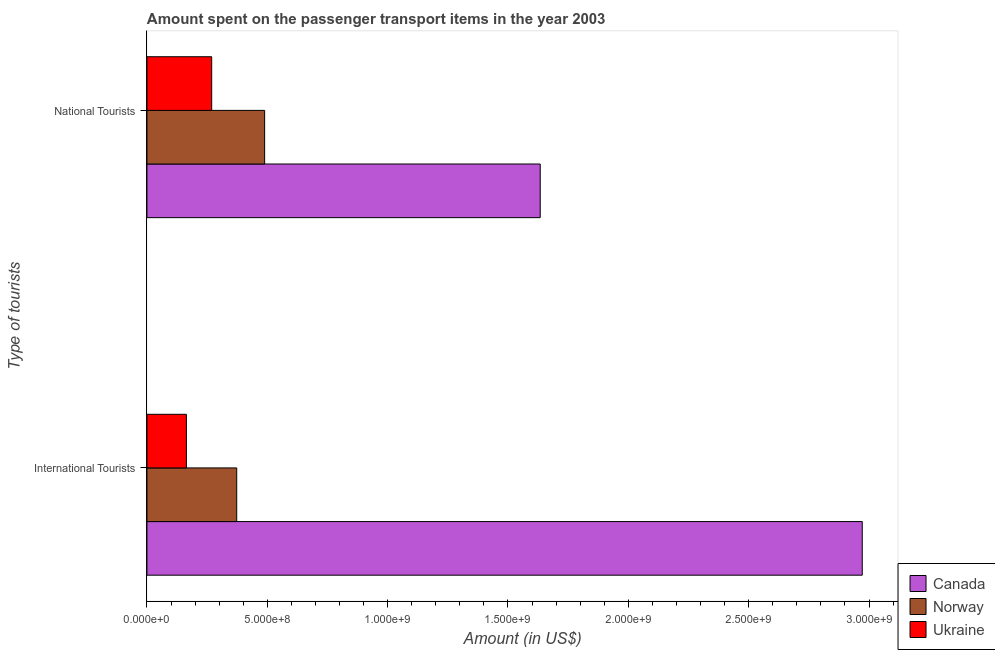How many different coloured bars are there?
Give a very brief answer. 3. Are the number of bars per tick equal to the number of legend labels?
Keep it short and to the point. Yes. How many bars are there on the 2nd tick from the top?
Offer a very short reply. 3. What is the label of the 1st group of bars from the top?
Provide a succinct answer. National Tourists. What is the amount spent on transport items of international tourists in Norway?
Give a very brief answer. 3.73e+08. Across all countries, what is the maximum amount spent on transport items of international tourists?
Provide a short and direct response. 2.97e+09. Across all countries, what is the minimum amount spent on transport items of international tourists?
Offer a very short reply. 1.64e+08. In which country was the amount spent on transport items of national tourists maximum?
Your answer should be very brief. Canada. In which country was the amount spent on transport items of international tourists minimum?
Keep it short and to the point. Ukraine. What is the total amount spent on transport items of national tourists in the graph?
Your response must be concise. 2.39e+09. What is the difference between the amount spent on transport items of international tourists in Norway and that in Ukraine?
Provide a succinct answer. 2.09e+08. What is the difference between the amount spent on transport items of international tourists in Norway and the amount spent on transport items of national tourists in Ukraine?
Ensure brevity in your answer.  1.04e+08. What is the average amount spent on transport items of national tourists per country?
Keep it short and to the point. 7.97e+08. What is the difference between the amount spent on transport items of national tourists and amount spent on transport items of international tourists in Canada?
Your answer should be very brief. -1.34e+09. What is the ratio of the amount spent on transport items of international tourists in Ukraine to that in Norway?
Offer a terse response. 0.44. Is the amount spent on transport items of national tourists in Canada less than that in Ukraine?
Offer a very short reply. No. In how many countries, is the amount spent on transport items of international tourists greater than the average amount spent on transport items of international tourists taken over all countries?
Your response must be concise. 1. What does the 1st bar from the top in International Tourists represents?
Provide a succinct answer. Ukraine. What does the 1st bar from the bottom in International Tourists represents?
Provide a succinct answer. Canada. Are all the bars in the graph horizontal?
Provide a short and direct response. Yes. What is the difference between two consecutive major ticks on the X-axis?
Ensure brevity in your answer.  5.00e+08. Does the graph contain grids?
Provide a succinct answer. No. Where does the legend appear in the graph?
Give a very brief answer. Bottom right. How many legend labels are there?
Offer a terse response. 3. How are the legend labels stacked?
Keep it short and to the point. Vertical. What is the title of the graph?
Your response must be concise. Amount spent on the passenger transport items in the year 2003. Does "Libya" appear as one of the legend labels in the graph?
Your response must be concise. No. What is the label or title of the Y-axis?
Provide a succinct answer. Type of tourists. What is the Amount (in US$) of Canada in International Tourists?
Provide a succinct answer. 2.97e+09. What is the Amount (in US$) in Norway in International Tourists?
Keep it short and to the point. 3.73e+08. What is the Amount (in US$) of Ukraine in International Tourists?
Offer a terse response. 1.64e+08. What is the Amount (in US$) in Canada in National Tourists?
Your answer should be compact. 1.63e+09. What is the Amount (in US$) of Norway in National Tourists?
Provide a succinct answer. 4.89e+08. What is the Amount (in US$) of Ukraine in National Tourists?
Provide a short and direct response. 2.69e+08. Across all Type of tourists, what is the maximum Amount (in US$) in Canada?
Give a very brief answer. 2.97e+09. Across all Type of tourists, what is the maximum Amount (in US$) in Norway?
Offer a very short reply. 4.89e+08. Across all Type of tourists, what is the maximum Amount (in US$) in Ukraine?
Your answer should be compact. 2.69e+08. Across all Type of tourists, what is the minimum Amount (in US$) of Canada?
Provide a short and direct response. 1.63e+09. Across all Type of tourists, what is the minimum Amount (in US$) of Norway?
Ensure brevity in your answer.  3.73e+08. Across all Type of tourists, what is the minimum Amount (in US$) of Ukraine?
Your response must be concise. 1.64e+08. What is the total Amount (in US$) in Canada in the graph?
Your answer should be compact. 4.61e+09. What is the total Amount (in US$) of Norway in the graph?
Make the answer very short. 8.62e+08. What is the total Amount (in US$) in Ukraine in the graph?
Make the answer very short. 4.33e+08. What is the difference between the Amount (in US$) of Canada in International Tourists and that in National Tourists?
Your answer should be very brief. 1.34e+09. What is the difference between the Amount (in US$) in Norway in International Tourists and that in National Tourists?
Make the answer very short. -1.16e+08. What is the difference between the Amount (in US$) of Ukraine in International Tourists and that in National Tourists?
Provide a succinct answer. -1.05e+08. What is the difference between the Amount (in US$) in Canada in International Tourists and the Amount (in US$) in Norway in National Tourists?
Offer a very short reply. 2.48e+09. What is the difference between the Amount (in US$) in Canada in International Tourists and the Amount (in US$) in Ukraine in National Tourists?
Make the answer very short. 2.70e+09. What is the difference between the Amount (in US$) in Norway in International Tourists and the Amount (in US$) in Ukraine in National Tourists?
Give a very brief answer. 1.04e+08. What is the average Amount (in US$) of Canada per Type of tourists?
Ensure brevity in your answer.  2.30e+09. What is the average Amount (in US$) in Norway per Type of tourists?
Your response must be concise. 4.31e+08. What is the average Amount (in US$) in Ukraine per Type of tourists?
Ensure brevity in your answer.  2.16e+08. What is the difference between the Amount (in US$) of Canada and Amount (in US$) of Norway in International Tourists?
Provide a succinct answer. 2.60e+09. What is the difference between the Amount (in US$) in Canada and Amount (in US$) in Ukraine in International Tourists?
Keep it short and to the point. 2.81e+09. What is the difference between the Amount (in US$) of Norway and Amount (in US$) of Ukraine in International Tourists?
Your answer should be compact. 2.09e+08. What is the difference between the Amount (in US$) of Canada and Amount (in US$) of Norway in National Tourists?
Provide a short and direct response. 1.14e+09. What is the difference between the Amount (in US$) in Canada and Amount (in US$) in Ukraine in National Tourists?
Keep it short and to the point. 1.36e+09. What is the difference between the Amount (in US$) in Norway and Amount (in US$) in Ukraine in National Tourists?
Provide a short and direct response. 2.20e+08. What is the ratio of the Amount (in US$) in Canada in International Tourists to that in National Tourists?
Your response must be concise. 1.82. What is the ratio of the Amount (in US$) in Norway in International Tourists to that in National Tourists?
Keep it short and to the point. 0.76. What is the ratio of the Amount (in US$) in Ukraine in International Tourists to that in National Tourists?
Provide a succinct answer. 0.61. What is the difference between the highest and the second highest Amount (in US$) in Canada?
Provide a short and direct response. 1.34e+09. What is the difference between the highest and the second highest Amount (in US$) in Norway?
Offer a very short reply. 1.16e+08. What is the difference between the highest and the second highest Amount (in US$) in Ukraine?
Your answer should be very brief. 1.05e+08. What is the difference between the highest and the lowest Amount (in US$) of Canada?
Ensure brevity in your answer.  1.34e+09. What is the difference between the highest and the lowest Amount (in US$) of Norway?
Offer a very short reply. 1.16e+08. What is the difference between the highest and the lowest Amount (in US$) in Ukraine?
Your answer should be compact. 1.05e+08. 